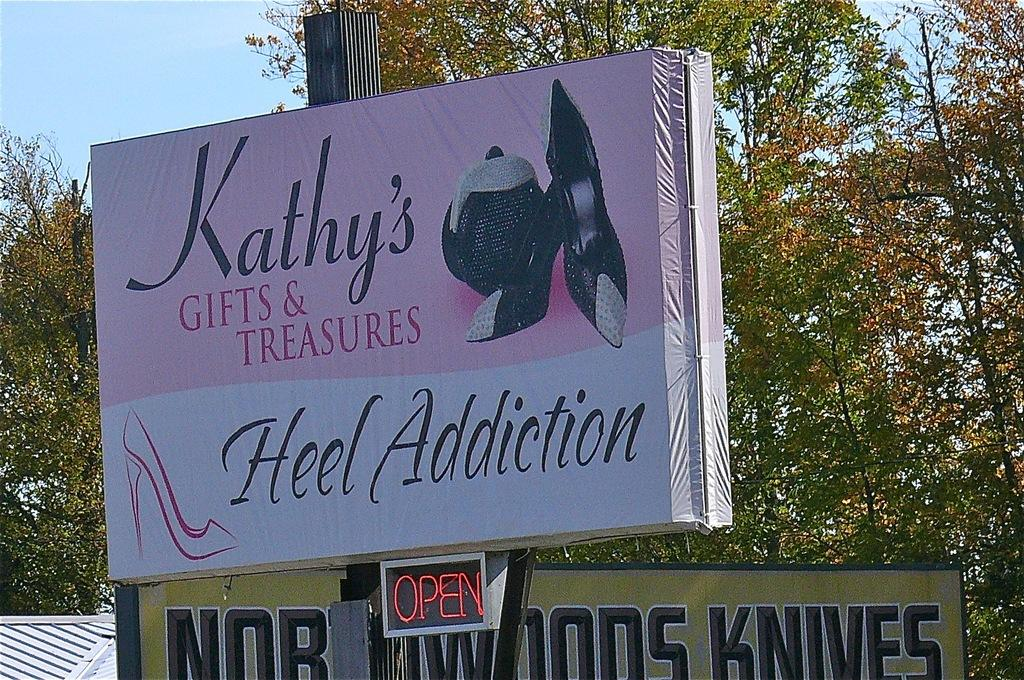<image>
Share a concise interpretation of the image provided. the words heel addiction that are on a sign 